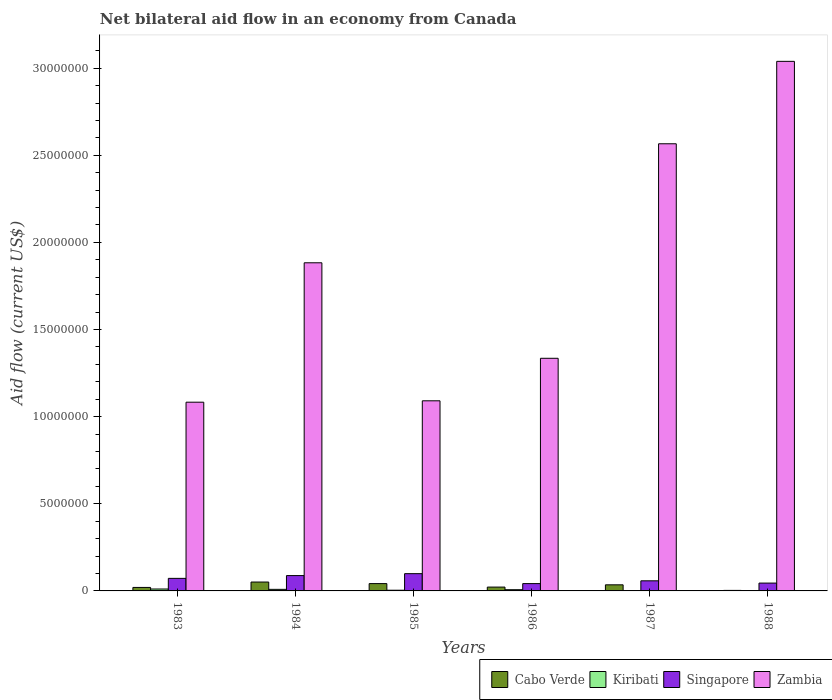Are the number of bars per tick equal to the number of legend labels?
Your response must be concise. Yes. What is the label of the 3rd group of bars from the left?
Offer a terse response. 1985. What is the net bilateral aid flow in Zambia in 1985?
Provide a succinct answer. 1.09e+07. Across all years, what is the minimum net bilateral aid flow in Singapore?
Ensure brevity in your answer.  4.20e+05. In which year was the net bilateral aid flow in Singapore minimum?
Provide a short and direct response. 1986. What is the total net bilateral aid flow in Zambia in the graph?
Keep it short and to the point. 1.10e+08. What is the difference between the net bilateral aid flow in Zambia in 1983 and that in 1986?
Provide a succinct answer. -2.52e+06. What is the difference between the net bilateral aid flow in Singapore in 1986 and the net bilateral aid flow in Zambia in 1985?
Keep it short and to the point. -1.05e+07. What is the average net bilateral aid flow in Zambia per year?
Keep it short and to the point. 1.83e+07. In the year 1984, what is the difference between the net bilateral aid flow in Kiribati and net bilateral aid flow in Cabo Verde?
Your answer should be very brief. -4.20e+05. In how many years, is the net bilateral aid flow in Singapore greater than 28000000 US$?
Ensure brevity in your answer.  0. What is the ratio of the net bilateral aid flow in Cabo Verde in 1987 to that in 1988?
Give a very brief answer. 11.67. Is the net bilateral aid flow in Kiribati in 1984 less than that in 1986?
Your answer should be very brief. No. What is the difference between the highest and the second highest net bilateral aid flow in Zambia?
Give a very brief answer. 4.73e+06. What is the difference between the highest and the lowest net bilateral aid flow in Singapore?
Provide a short and direct response. 5.70e+05. In how many years, is the net bilateral aid flow in Singapore greater than the average net bilateral aid flow in Singapore taken over all years?
Give a very brief answer. 3. Is the sum of the net bilateral aid flow in Zambia in 1983 and 1985 greater than the maximum net bilateral aid flow in Kiribati across all years?
Offer a very short reply. Yes. What does the 1st bar from the left in 1986 represents?
Provide a succinct answer. Cabo Verde. What does the 4th bar from the right in 1986 represents?
Ensure brevity in your answer.  Cabo Verde. Is it the case that in every year, the sum of the net bilateral aid flow in Kiribati and net bilateral aid flow in Singapore is greater than the net bilateral aid flow in Zambia?
Ensure brevity in your answer.  No. What is the difference between two consecutive major ticks on the Y-axis?
Your response must be concise. 5.00e+06. Are the values on the major ticks of Y-axis written in scientific E-notation?
Give a very brief answer. No. Does the graph contain any zero values?
Offer a very short reply. No. Where does the legend appear in the graph?
Make the answer very short. Bottom right. How many legend labels are there?
Ensure brevity in your answer.  4. What is the title of the graph?
Make the answer very short. Net bilateral aid flow in an economy from Canada. What is the label or title of the X-axis?
Provide a succinct answer. Years. What is the label or title of the Y-axis?
Ensure brevity in your answer.  Aid flow (current US$). What is the Aid flow (current US$) of Singapore in 1983?
Give a very brief answer. 7.20e+05. What is the Aid flow (current US$) of Zambia in 1983?
Offer a very short reply. 1.08e+07. What is the Aid flow (current US$) of Cabo Verde in 1984?
Your answer should be very brief. 5.10e+05. What is the Aid flow (current US$) of Singapore in 1984?
Make the answer very short. 8.80e+05. What is the Aid flow (current US$) of Zambia in 1984?
Your response must be concise. 1.88e+07. What is the Aid flow (current US$) in Kiribati in 1985?
Make the answer very short. 4.00e+04. What is the Aid flow (current US$) of Singapore in 1985?
Make the answer very short. 9.90e+05. What is the Aid flow (current US$) of Zambia in 1985?
Ensure brevity in your answer.  1.09e+07. What is the Aid flow (current US$) in Kiribati in 1986?
Provide a succinct answer. 7.00e+04. What is the Aid flow (current US$) of Singapore in 1986?
Give a very brief answer. 4.20e+05. What is the Aid flow (current US$) in Zambia in 1986?
Your answer should be very brief. 1.34e+07. What is the Aid flow (current US$) of Cabo Verde in 1987?
Your answer should be very brief. 3.50e+05. What is the Aid flow (current US$) in Kiribati in 1987?
Your answer should be compact. 10000. What is the Aid flow (current US$) in Singapore in 1987?
Your response must be concise. 5.80e+05. What is the Aid flow (current US$) in Zambia in 1987?
Make the answer very short. 2.57e+07. What is the Aid flow (current US$) of Kiribati in 1988?
Offer a very short reply. 10000. What is the Aid flow (current US$) of Zambia in 1988?
Your answer should be compact. 3.04e+07. Across all years, what is the maximum Aid flow (current US$) in Cabo Verde?
Give a very brief answer. 5.10e+05. Across all years, what is the maximum Aid flow (current US$) of Kiribati?
Your answer should be compact. 1.10e+05. Across all years, what is the maximum Aid flow (current US$) of Singapore?
Your response must be concise. 9.90e+05. Across all years, what is the maximum Aid flow (current US$) of Zambia?
Provide a succinct answer. 3.04e+07. Across all years, what is the minimum Aid flow (current US$) of Singapore?
Your response must be concise. 4.20e+05. Across all years, what is the minimum Aid flow (current US$) in Zambia?
Make the answer very short. 1.08e+07. What is the total Aid flow (current US$) of Cabo Verde in the graph?
Your response must be concise. 1.73e+06. What is the total Aid flow (current US$) in Singapore in the graph?
Ensure brevity in your answer.  4.04e+06. What is the total Aid flow (current US$) in Zambia in the graph?
Keep it short and to the point. 1.10e+08. What is the difference between the Aid flow (current US$) of Cabo Verde in 1983 and that in 1984?
Provide a succinct answer. -3.10e+05. What is the difference between the Aid flow (current US$) of Zambia in 1983 and that in 1984?
Ensure brevity in your answer.  -8.00e+06. What is the difference between the Aid flow (current US$) of Kiribati in 1983 and that in 1985?
Keep it short and to the point. 7.00e+04. What is the difference between the Aid flow (current US$) of Singapore in 1983 and that in 1985?
Your answer should be compact. -2.70e+05. What is the difference between the Aid flow (current US$) of Zambia in 1983 and that in 1985?
Ensure brevity in your answer.  -8.00e+04. What is the difference between the Aid flow (current US$) in Cabo Verde in 1983 and that in 1986?
Make the answer very short. -2.00e+04. What is the difference between the Aid flow (current US$) of Kiribati in 1983 and that in 1986?
Offer a very short reply. 4.00e+04. What is the difference between the Aid flow (current US$) in Zambia in 1983 and that in 1986?
Ensure brevity in your answer.  -2.52e+06. What is the difference between the Aid flow (current US$) of Kiribati in 1983 and that in 1987?
Your answer should be very brief. 1.00e+05. What is the difference between the Aid flow (current US$) of Singapore in 1983 and that in 1987?
Provide a succinct answer. 1.40e+05. What is the difference between the Aid flow (current US$) of Zambia in 1983 and that in 1987?
Make the answer very short. -1.48e+07. What is the difference between the Aid flow (current US$) of Cabo Verde in 1983 and that in 1988?
Your response must be concise. 1.70e+05. What is the difference between the Aid flow (current US$) of Kiribati in 1983 and that in 1988?
Your answer should be compact. 1.00e+05. What is the difference between the Aid flow (current US$) in Zambia in 1983 and that in 1988?
Give a very brief answer. -1.96e+07. What is the difference between the Aid flow (current US$) in Cabo Verde in 1984 and that in 1985?
Provide a succinct answer. 9.00e+04. What is the difference between the Aid flow (current US$) in Zambia in 1984 and that in 1985?
Ensure brevity in your answer.  7.92e+06. What is the difference between the Aid flow (current US$) in Kiribati in 1984 and that in 1986?
Offer a very short reply. 2.00e+04. What is the difference between the Aid flow (current US$) of Singapore in 1984 and that in 1986?
Your answer should be compact. 4.60e+05. What is the difference between the Aid flow (current US$) in Zambia in 1984 and that in 1986?
Give a very brief answer. 5.48e+06. What is the difference between the Aid flow (current US$) of Cabo Verde in 1984 and that in 1987?
Provide a succinct answer. 1.60e+05. What is the difference between the Aid flow (current US$) in Zambia in 1984 and that in 1987?
Provide a short and direct response. -6.83e+06. What is the difference between the Aid flow (current US$) in Kiribati in 1984 and that in 1988?
Your answer should be compact. 8.00e+04. What is the difference between the Aid flow (current US$) of Zambia in 1984 and that in 1988?
Your answer should be compact. -1.16e+07. What is the difference between the Aid flow (current US$) of Kiribati in 1985 and that in 1986?
Offer a terse response. -3.00e+04. What is the difference between the Aid flow (current US$) in Singapore in 1985 and that in 1986?
Ensure brevity in your answer.  5.70e+05. What is the difference between the Aid flow (current US$) in Zambia in 1985 and that in 1986?
Offer a terse response. -2.44e+06. What is the difference between the Aid flow (current US$) of Cabo Verde in 1985 and that in 1987?
Your response must be concise. 7.00e+04. What is the difference between the Aid flow (current US$) in Zambia in 1985 and that in 1987?
Your answer should be compact. -1.48e+07. What is the difference between the Aid flow (current US$) in Cabo Verde in 1985 and that in 1988?
Keep it short and to the point. 3.90e+05. What is the difference between the Aid flow (current US$) in Kiribati in 1985 and that in 1988?
Your response must be concise. 3.00e+04. What is the difference between the Aid flow (current US$) of Singapore in 1985 and that in 1988?
Your answer should be very brief. 5.40e+05. What is the difference between the Aid flow (current US$) in Zambia in 1985 and that in 1988?
Ensure brevity in your answer.  -1.95e+07. What is the difference between the Aid flow (current US$) in Kiribati in 1986 and that in 1987?
Ensure brevity in your answer.  6.00e+04. What is the difference between the Aid flow (current US$) in Zambia in 1986 and that in 1987?
Offer a very short reply. -1.23e+07. What is the difference between the Aid flow (current US$) in Singapore in 1986 and that in 1988?
Keep it short and to the point. -3.00e+04. What is the difference between the Aid flow (current US$) in Zambia in 1986 and that in 1988?
Provide a succinct answer. -1.70e+07. What is the difference between the Aid flow (current US$) in Kiribati in 1987 and that in 1988?
Your answer should be compact. 0. What is the difference between the Aid flow (current US$) in Singapore in 1987 and that in 1988?
Your response must be concise. 1.30e+05. What is the difference between the Aid flow (current US$) in Zambia in 1987 and that in 1988?
Keep it short and to the point. -4.73e+06. What is the difference between the Aid flow (current US$) of Cabo Verde in 1983 and the Aid flow (current US$) of Singapore in 1984?
Provide a short and direct response. -6.80e+05. What is the difference between the Aid flow (current US$) of Cabo Verde in 1983 and the Aid flow (current US$) of Zambia in 1984?
Offer a terse response. -1.86e+07. What is the difference between the Aid flow (current US$) of Kiribati in 1983 and the Aid flow (current US$) of Singapore in 1984?
Your answer should be very brief. -7.70e+05. What is the difference between the Aid flow (current US$) in Kiribati in 1983 and the Aid flow (current US$) in Zambia in 1984?
Provide a succinct answer. -1.87e+07. What is the difference between the Aid flow (current US$) of Singapore in 1983 and the Aid flow (current US$) of Zambia in 1984?
Keep it short and to the point. -1.81e+07. What is the difference between the Aid flow (current US$) in Cabo Verde in 1983 and the Aid flow (current US$) in Kiribati in 1985?
Offer a terse response. 1.60e+05. What is the difference between the Aid flow (current US$) of Cabo Verde in 1983 and the Aid flow (current US$) of Singapore in 1985?
Your response must be concise. -7.90e+05. What is the difference between the Aid flow (current US$) of Cabo Verde in 1983 and the Aid flow (current US$) of Zambia in 1985?
Ensure brevity in your answer.  -1.07e+07. What is the difference between the Aid flow (current US$) in Kiribati in 1983 and the Aid flow (current US$) in Singapore in 1985?
Offer a terse response. -8.80e+05. What is the difference between the Aid flow (current US$) in Kiribati in 1983 and the Aid flow (current US$) in Zambia in 1985?
Provide a short and direct response. -1.08e+07. What is the difference between the Aid flow (current US$) in Singapore in 1983 and the Aid flow (current US$) in Zambia in 1985?
Offer a very short reply. -1.02e+07. What is the difference between the Aid flow (current US$) in Cabo Verde in 1983 and the Aid flow (current US$) in Singapore in 1986?
Offer a terse response. -2.20e+05. What is the difference between the Aid flow (current US$) of Cabo Verde in 1983 and the Aid flow (current US$) of Zambia in 1986?
Your answer should be very brief. -1.32e+07. What is the difference between the Aid flow (current US$) of Kiribati in 1983 and the Aid flow (current US$) of Singapore in 1986?
Make the answer very short. -3.10e+05. What is the difference between the Aid flow (current US$) of Kiribati in 1983 and the Aid flow (current US$) of Zambia in 1986?
Your answer should be very brief. -1.32e+07. What is the difference between the Aid flow (current US$) of Singapore in 1983 and the Aid flow (current US$) of Zambia in 1986?
Your answer should be compact. -1.26e+07. What is the difference between the Aid flow (current US$) in Cabo Verde in 1983 and the Aid flow (current US$) in Singapore in 1987?
Provide a short and direct response. -3.80e+05. What is the difference between the Aid flow (current US$) of Cabo Verde in 1983 and the Aid flow (current US$) of Zambia in 1987?
Provide a succinct answer. -2.55e+07. What is the difference between the Aid flow (current US$) of Kiribati in 1983 and the Aid flow (current US$) of Singapore in 1987?
Give a very brief answer. -4.70e+05. What is the difference between the Aid flow (current US$) of Kiribati in 1983 and the Aid flow (current US$) of Zambia in 1987?
Offer a terse response. -2.56e+07. What is the difference between the Aid flow (current US$) in Singapore in 1983 and the Aid flow (current US$) in Zambia in 1987?
Make the answer very short. -2.49e+07. What is the difference between the Aid flow (current US$) of Cabo Verde in 1983 and the Aid flow (current US$) of Singapore in 1988?
Provide a short and direct response. -2.50e+05. What is the difference between the Aid flow (current US$) of Cabo Verde in 1983 and the Aid flow (current US$) of Zambia in 1988?
Your answer should be compact. -3.02e+07. What is the difference between the Aid flow (current US$) in Kiribati in 1983 and the Aid flow (current US$) in Singapore in 1988?
Provide a short and direct response. -3.40e+05. What is the difference between the Aid flow (current US$) of Kiribati in 1983 and the Aid flow (current US$) of Zambia in 1988?
Offer a terse response. -3.03e+07. What is the difference between the Aid flow (current US$) in Singapore in 1983 and the Aid flow (current US$) in Zambia in 1988?
Give a very brief answer. -2.97e+07. What is the difference between the Aid flow (current US$) of Cabo Verde in 1984 and the Aid flow (current US$) of Singapore in 1985?
Make the answer very short. -4.80e+05. What is the difference between the Aid flow (current US$) in Cabo Verde in 1984 and the Aid flow (current US$) in Zambia in 1985?
Offer a very short reply. -1.04e+07. What is the difference between the Aid flow (current US$) in Kiribati in 1984 and the Aid flow (current US$) in Singapore in 1985?
Ensure brevity in your answer.  -9.00e+05. What is the difference between the Aid flow (current US$) of Kiribati in 1984 and the Aid flow (current US$) of Zambia in 1985?
Offer a terse response. -1.08e+07. What is the difference between the Aid flow (current US$) in Singapore in 1984 and the Aid flow (current US$) in Zambia in 1985?
Give a very brief answer. -1.00e+07. What is the difference between the Aid flow (current US$) in Cabo Verde in 1984 and the Aid flow (current US$) in Kiribati in 1986?
Your response must be concise. 4.40e+05. What is the difference between the Aid flow (current US$) of Cabo Verde in 1984 and the Aid flow (current US$) of Singapore in 1986?
Offer a terse response. 9.00e+04. What is the difference between the Aid flow (current US$) in Cabo Verde in 1984 and the Aid flow (current US$) in Zambia in 1986?
Provide a succinct answer. -1.28e+07. What is the difference between the Aid flow (current US$) in Kiribati in 1984 and the Aid flow (current US$) in Singapore in 1986?
Keep it short and to the point. -3.30e+05. What is the difference between the Aid flow (current US$) in Kiribati in 1984 and the Aid flow (current US$) in Zambia in 1986?
Offer a very short reply. -1.33e+07. What is the difference between the Aid flow (current US$) in Singapore in 1984 and the Aid flow (current US$) in Zambia in 1986?
Your response must be concise. -1.25e+07. What is the difference between the Aid flow (current US$) of Cabo Verde in 1984 and the Aid flow (current US$) of Kiribati in 1987?
Provide a succinct answer. 5.00e+05. What is the difference between the Aid flow (current US$) of Cabo Verde in 1984 and the Aid flow (current US$) of Zambia in 1987?
Offer a very short reply. -2.52e+07. What is the difference between the Aid flow (current US$) in Kiribati in 1984 and the Aid flow (current US$) in Singapore in 1987?
Offer a terse response. -4.90e+05. What is the difference between the Aid flow (current US$) in Kiribati in 1984 and the Aid flow (current US$) in Zambia in 1987?
Provide a succinct answer. -2.56e+07. What is the difference between the Aid flow (current US$) of Singapore in 1984 and the Aid flow (current US$) of Zambia in 1987?
Make the answer very short. -2.48e+07. What is the difference between the Aid flow (current US$) of Cabo Verde in 1984 and the Aid flow (current US$) of Kiribati in 1988?
Make the answer very short. 5.00e+05. What is the difference between the Aid flow (current US$) in Cabo Verde in 1984 and the Aid flow (current US$) in Zambia in 1988?
Make the answer very short. -2.99e+07. What is the difference between the Aid flow (current US$) of Kiribati in 1984 and the Aid flow (current US$) of Singapore in 1988?
Provide a succinct answer. -3.60e+05. What is the difference between the Aid flow (current US$) of Kiribati in 1984 and the Aid flow (current US$) of Zambia in 1988?
Provide a succinct answer. -3.03e+07. What is the difference between the Aid flow (current US$) of Singapore in 1984 and the Aid flow (current US$) of Zambia in 1988?
Provide a succinct answer. -2.95e+07. What is the difference between the Aid flow (current US$) of Cabo Verde in 1985 and the Aid flow (current US$) of Singapore in 1986?
Give a very brief answer. 0. What is the difference between the Aid flow (current US$) in Cabo Verde in 1985 and the Aid flow (current US$) in Zambia in 1986?
Ensure brevity in your answer.  -1.29e+07. What is the difference between the Aid flow (current US$) of Kiribati in 1985 and the Aid flow (current US$) of Singapore in 1986?
Ensure brevity in your answer.  -3.80e+05. What is the difference between the Aid flow (current US$) in Kiribati in 1985 and the Aid flow (current US$) in Zambia in 1986?
Your response must be concise. -1.33e+07. What is the difference between the Aid flow (current US$) in Singapore in 1985 and the Aid flow (current US$) in Zambia in 1986?
Provide a short and direct response. -1.24e+07. What is the difference between the Aid flow (current US$) in Cabo Verde in 1985 and the Aid flow (current US$) in Zambia in 1987?
Offer a terse response. -2.52e+07. What is the difference between the Aid flow (current US$) in Kiribati in 1985 and the Aid flow (current US$) in Singapore in 1987?
Give a very brief answer. -5.40e+05. What is the difference between the Aid flow (current US$) in Kiribati in 1985 and the Aid flow (current US$) in Zambia in 1987?
Your answer should be compact. -2.56e+07. What is the difference between the Aid flow (current US$) in Singapore in 1985 and the Aid flow (current US$) in Zambia in 1987?
Provide a succinct answer. -2.47e+07. What is the difference between the Aid flow (current US$) of Cabo Verde in 1985 and the Aid flow (current US$) of Singapore in 1988?
Offer a very short reply. -3.00e+04. What is the difference between the Aid flow (current US$) of Cabo Verde in 1985 and the Aid flow (current US$) of Zambia in 1988?
Your answer should be very brief. -3.00e+07. What is the difference between the Aid flow (current US$) of Kiribati in 1985 and the Aid flow (current US$) of Singapore in 1988?
Your answer should be very brief. -4.10e+05. What is the difference between the Aid flow (current US$) in Kiribati in 1985 and the Aid flow (current US$) in Zambia in 1988?
Offer a very short reply. -3.04e+07. What is the difference between the Aid flow (current US$) of Singapore in 1985 and the Aid flow (current US$) of Zambia in 1988?
Ensure brevity in your answer.  -2.94e+07. What is the difference between the Aid flow (current US$) of Cabo Verde in 1986 and the Aid flow (current US$) of Kiribati in 1987?
Provide a short and direct response. 2.10e+05. What is the difference between the Aid flow (current US$) in Cabo Verde in 1986 and the Aid flow (current US$) in Singapore in 1987?
Make the answer very short. -3.60e+05. What is the difference between the Aid flow (current US$) of Cabo Verde in 1986 and the Aid flow (current US$) of Zambia in 1987?
Keep it short and to the point. -2.54e+07. What is the difference between the Aid flow (current US$) in Kiribati in 1986 and the Aid flow (current US$) in Singapore in 1987?
Offer a very short reply. -5.10e+05. What is the difference between the Aid flow (current US$) of Kiribati in 1986 and the Aid flow (current US$) of Zambia in 1987?
Provide a short and direct response. -2.56e+07. What is the difference between the Aid flow (current US$) of Singapore in 1986 and the Aid flow (current US$) of Zambia in 1987?
Provide a short and direct response. -2.52e+07. What is the difference between the Aid flow (current US$) of Cabo Verde in 1986 and the Aid flow (current US$) of Zambia in 1988?
Provide a succinct answer. -3.02e+07. What is the difference between the Aid flow (current US$) in Kiribati in 1986 and the Aid flow (current US$) in Singapore in 1988?
Ensure brevity in your answer.  -3.80e+05. What is the difference between the Aid flow (current US$) in Kiribati in 1986 and the Aid flow (current US$) in Zambia in 1988?
Offer a terse response. -3.03e+07. What is the difference between the Aid flow (current US$) of Singapore in 1986 and the Aid flow (current US$) of Zambia in 1988?
Provide a short and direct response. -3.00e+07. What is the difference between the Aid flow (current US$) of Cabo Verde in 1987 and the Aid flow (current US$) of Kiribati in 1988?
Provide a succinct answer. 3.40e+05. What is the difference between the Aid flow (current US$) in Cabo Verde in 1987 and the Aid flow (current US$) in Singapore in 1988?
Give a very brief answer. -1.00e+05. What is the difference between the Aid flow (current US$) of Cabo Verde in 1987 and the Aid flow (current US$) of Zambia in 1988?
Provide a succinct answer. -3.00e+07. What is the difference between the Aid flow (current US$) in Kiribati in 1987 and the Aid flow (current US$) in Singapore in 1988?
Your answer should be very brief. -4.40e+05. What is the difference between the Aid flow (current US$) in Kiribati in 1987 and the Aid flow (current US$) in Zambia in 1988?
Your response must be concise. -3.04e+07. What is the difference between the Aid flow (current US$) of Singapore in 1987 and the Aid flow (current US$) of Zambia in 1988?
Ensure brevity in your answer.  -2.98e+07. What is the average Aid flow (current US$) of Cabo Verde per year?
Ensure brevity in your answer.  2.88e+05. What is the average Aid flow (current US$) in Kiribati per year?
Offer a very short reply. 5.50e+04. What is the average Aid flow (current US$) of Singapore per year?
Your response must be concise. 6.73e+05. What is the average Aid flow (current US$) in Zambia per year?
Offer a terse response. 1.83e+07. In the year 1983, what is the difference between the Aid flow (current US$) in Cabo Verde and Aid flow (current US$) in Kiribati?
Ensure brevity in your answer.  9.00e+04. In the year 1983, what is the difference between the Aid flow (current US$) in Cabo Verde and Aid flow (current US$) in Singapore?
Make the answer very short. -5.20e+05. In the year 1983, what is the difference between the Aid flow (current US$) of Cabo Verde and Aid flow (current US$) of Zambia?
Ensure brevity in your answer.  -1.06e+07. In the year 1983, what is the difference between the Aid flow (current US$) in Kiribati and Aid flow (current US$) in Singapore?
Provide a short and direct response. -6.10e+05. In the year 1983, what is the difference between the Aid flow (current US$) of Kiribati and Aid flow (current US$) of Zambia?
Your answer should be compact. -1.07e+07. In the year 1983, what is the difference between the Aid flow (current US$) of Singapore and Aid flow (current US$) of Zambia?
Offer a terse response. -1.01e+07. In the year 1984, what is the difference between the Aid flow (current US$) of Cabo Verde and Aid flow (current US$) of Singapore?
Your response must be concise. -3.70e+05. In the year 1984, what is the difference between the Aid flow (current US$) of Cabo Verde and Aid flow (current US$) of Zambia?
Offer a terse response. -1.83e+07. In the year 1984, what is the difference between the Aid flow (current US$) in Kiribati and Aid flow (current US$) in Singapore?
Offer a terse response. -7.90e+05. In the year 1984, what is the difference between the Aid flow (current US$) in Kiribati and Aid flow (current US$) in Zambia?
Give a very brief answer. -1.87e+07. In the year 1984, what is the difference between the Aid flow (current US$) of Singapore and Aid flow (current US$) of Zambia?
Your response must be concise. -1.80e+07. In the year 1985, what is the difference between the Aid flow (current US$) of Cabo Verde and Aid flow (current US$) of Kiribati?
Keep it short and to the point. 3.80e+05. In the year 1985, what is the difference between the Aid flow (current US$) of Cabo Verde and Aid flow (current US$) of Singapore?
Keep it short and to the point. -5.70e+05. In the year 1985, what is the difference between the Aid flow (current US$) in Cabo Verde and Aid flow (current US$) in Zambia?
Offer a very short reply. -1.05e+07. In the year 1985, what is the difference between the Aid flow (current US$) in Kiribati and Aid flow (current US$) in Singapore?
Provide a short and direct response. -9.50e+05. In the year 1985, what is the difference between the Aid flow (current US$) in Kiribati and Aid flow (current US$) in Zambia?
Ensure brevity in your answer.  -1.09e+07. In the year 1985, what is the difference between the Aid flow (current US$) of Singapore and Aid flow (current US$) of Zambia?
Your response must be concise. -9.92e+06. In the year 1986, what is the difference between the Aid flow (current US$) in Cabo Verde and Aid flow (current US$) in Zambia?
Give a very brief answer. -1.31e+07. In the year 1986, what is the difference between the Aid flow (current US$) of Kiribati and Aid flow (current US$) of Singapore?
Give a very brief answer. -3.50e+05. In the year 1986, what is the difference between the Aid flow (current US$) in Kiribati and Aid flow (current US$) in Zambia?
Make the answer very short. -1.33e+07. In the year 1986, what is the difference between the Aid flow (current US$) in Singapore and Aid flow (current US$) in Zambia?
Give a very brief answer. -1.29e+07. In the year 1987, what is the difference between the Aid flow (current US$) of Cabo Verde and Aid flow (current US$) of Zambia?
Offer a terse response. -2.53e+07. In the year 1987, what is the difference between the Aid flow (current US$) of Kiribati and Aid flow (current US$) of Singapore?
Offer a very short reply. -5.70e+05. In the year 1987, what is the difference between the Aid flow (current US$) of Kiribati and Aid flow (current US$) of Zambia?
Keep it short and to the point. -2.56e+07. In the year 1987, what is the difference between the Aid flow (current US$) in Singapore and Aid flow (current US$) in Zambia?
Ensure brevity in your answer.  -2.51e+07. In the year 1988, what is the difference between the Aid flow (current US$) of Cabo Verde and Aid flow (current US$) of Kiribati?
Provide a succinct answer. 2.00e+04. In the year 1988, what is the difference between the Aid flow (current US$) in Cabo Verde and Aid flow (current US$) in Singapore?
Offer a very short reply. -4.20e+05. In the year 1988, what is the difference between the Aid flow (current US$) of Cabo Verde and Aid flow (current US$) of Zambia?
Keep it short and to the point. -3.04e+07. In the year 1988, what is the difference between the Aid flow (current US$) of Kiribati and Aid flow (current US$) of Singapore?
Your answer should be compact. -4.40e+05. In the year 1988, what is the difference between the Aid flow (current US$) of Kiribati and Aid flow (current US$) of Zambia?
Offer a terse response. -3.04e+07. In the year 1988, what is the difference between the Aid flow (current US$) of Singapore and Aid flow (current US$) of Zambia?
Ensure brevity in your answer.  -2.99e+07. What is the ratio of the Aid flow (current US$) in Cabo Verde in 1983 to that in 1984?
Your answer should be compact. 0.39. What is the ratio of the Aid flow (current US$) in Kiribati in 1983 to that in 1984?
Offer a terse response. 1.22. What is the ratio of the Aid flow (current US$) in Singapore in 1983 to that in 1984?
Make the answer very short. 0.82. What is the ratio of the Aid flow (current US$) in Zambia in 1983 to that in 1984?
Offer a very short reply. 0.58. What is the ratio of the Aid flow (current US$) of Cabo Verde in 1983 to that in 1985?
Your response must be concise. 0.48. What is the ratio of the Aid flow (current US$) of Kiribati in 1983 to that in 1985?
Give a very brief answer. 2.75. What is the ratio of the Aid flow (current US$) in Singapore in 1983 to that in 1985?
Your answer should be very brief. 0.73. What is the ratio of the Aid flow (current US$) in Kiribati in 1983 to that in 1986?
Give a very brief answer. 1.57. What is the ratio of the Aid flow (current US$) in Singapore in 1983 to that in 1986?
Make the answer very short. 1.71. What is the ratio of the Aid flow (current US$) in Zambia in 1983 to that in 1986?
Provide a succinct answer. 0.81. What is the ratio of the Aid flow (current US$) of Cabo Verde in 1983 to that in 1987?
Make the answer very short. 0.57. What is the ratio of the Aid flow (current US$) of Kiribati in 1983 to that in 1987?
Give a very brief answer. 11. What is the ratio of the Aid flow (current US$) in Singapore in 1983 to that in 1987?
Make the answer very short. 1.24. What is the ratio of the Aid flow (current US$) in Zambia in 1983 to that in 1987?
Give a very brief answer. 0.42. What is the ratio of the Aid flow (current US$) of Kiribati in 1983 to that in 1988?
Provide a succinct answer. 11. What is the ratio of the Aid flow (current US$) of Zambia in 1983 to that in 1988?
Make the answer very short. 0.36. What is the ratio of the Aid flow (current US$) of Cabo Verde in 1984 to that in 1985?
Your response must be concise. 1.21. What is the ratio of the Aid flow (current US$) in Kiribati in 1984 to that in 1985?
Ensure brevity in your answer.  2.25. What is the ratio of the Aid flow (current US$) of Singapore in 1984 to that in 1985?
Provide a succinct answer. 0.89. What is the ratio of the Aid flow (current US$) in Zambia in 1984 to that in 1985?
Ensure brevity in your answer.  1.73. What is the ratio of the Aid flow (current US$) of Cabo Verde in 1984 to that in 1986?
Provide a succinct answer. 2.32. What is the ratio of the Aid flow (current US$) of Kiribati in 1984 to that in 1986?
Give a very brief answer. 1.29. What is the ratio of the Aid flow (current US$) of Singapore in 1984 to that in 1986?
Keep it short and to the point. 2.1. What is the ratio of the Aid flow (current US$) of Zambia in 1984 to that in 1986?
Offer a very short reply. 1.41. What is the ratio of the Aid flow (current US$) in Cabo Verde in 1984 to that in 1987?
Offer a very short reply. 1.46. What is the ratio of the Aid flow (current US$) of Kiribati in 1984 to that in 1987?
Ensure brevity in your answer.  9. What is the ratio of the Aid flow (current US$) in Singapore in 1984 to that in 1987?
Keep it short and to the point. 1.52. What is the ratio of the Aid flow (current US$) in Zambia in 1984 to that in 1987?
Ensure brevity in your answer.  0.73. What is the ratio of the Aid flow (current US$) in Cabo Verde in 1984 to that in 1988?
Keep it short and to the point. 17. What is the ratio of the Aid flow (current US$) in Singapore in 1984 to that in 1988?
Offer a terse response. 1.96. What is the ratio of the Aid flow (current US$) of Zambia in 1984 to that in 1988?
Offer a very short reply. 0.62. What is the ratio of the Aid flow (current US$) in Cabo Verde in 1985 to that in 1986?
Give a very brief answer. 1.91. What is the ratio of the Aid flow (current US$) of Singapore in 1985 to that in 1986?
Make the answer very short. 2.36. What is the ratio of the Aid flow (current US$) of Zambia in 1985 to that in 1986?
Offer a very short reply. 0.82. What is the ratio of the Aid flow (current US$) of Cabo Verde in 1985 to that in 1987?
Ensure brevity in your answer.  1.2. What is the ratio of the Aid flow (current US$) of Singapore in 1985 to that in 1987?
Your answer should be compact. 1.71. What is the ratio of the Aid flow (current US$) of Zambia in 1985 to that in 1987?
Give a very brief answer. 0.43. What is the ratio of the Aid flow (current US$) in Cabo Verde in 1985 to that in 1988?
Your answer should be very brief. 14. What is the ratio of the Aid flow (current US$) of Kiribati in 1985 to that in 1988?
Provide a succinct answer. 4. What is the ratio of the Aid flow (current US$) in Zambia in 1985 to that in 1988?
Provide a short and direct response. 0.36. What is the ratio of the Aid flow (current US$) of Cabo Verde in 1986 to that in 1987?
Provide a succinct answer. 0.63. What is the ratio of the Aid flow (current US$) of Kiribati in 1986 to that in 1987?
Your response must be concise. 7. What is the ratio of the Aid flow (current US$) in Singapore in 1986 to that in 1987?
Offer a terse response. 0.72. What is the ratio of the Aid flow (current US$) of Zambia in 1986 to that in 1987?
Keep it short and to the point. 0.52. What is the ratio of the Aid flow (current US$) of Cabo Verde in 1986 to that in 1988?
Your answer should be compact. 7.33. What is the ratio of the Aid flow (current US$) of Kiribati in 1986 to that in 1988?
Give a very brief answer. 7. What is the ratio of the Aid flow (current US$) in Zambia in 1986 to that in 1988?
Offer a very short reply. 0.44. What is the ratio of the Aid flow (current US$) of Cabo Verde in 1987 to that in 1988?
Your response must be concise. 11.67. What is the ratio of the Aid flow (current US$) of Kiribati in 1987 to that in 1988?
Make the answer very short. 1. What is the ratio of the Aid flow (current US$) of Singapore in 1987 to that in 1988?
Give a very brief answer. 1.29. What is the ratio of the Aid flow (current US$) in Zambia in 1987 to that in 1988?
Give a very brief answer. 0.84. What is the difference between the highest and the second highest Aid flow (current US$) of Zambia?
Your answer should be very brief. 4.73e+06. What is the difference between the highest and the lowest Aid flow (current US$) of Kiribati?
Your response must be concise. 1.00e+05. What is the difference between the highest and the lowest Aid flow (current US$) of Singapore?
Your response must be concise. 5.70e+05. What is the difference between the highest and the lowest Aid flow (current US$) of Zambia?
Your response must be concise. 1.96e+07. 